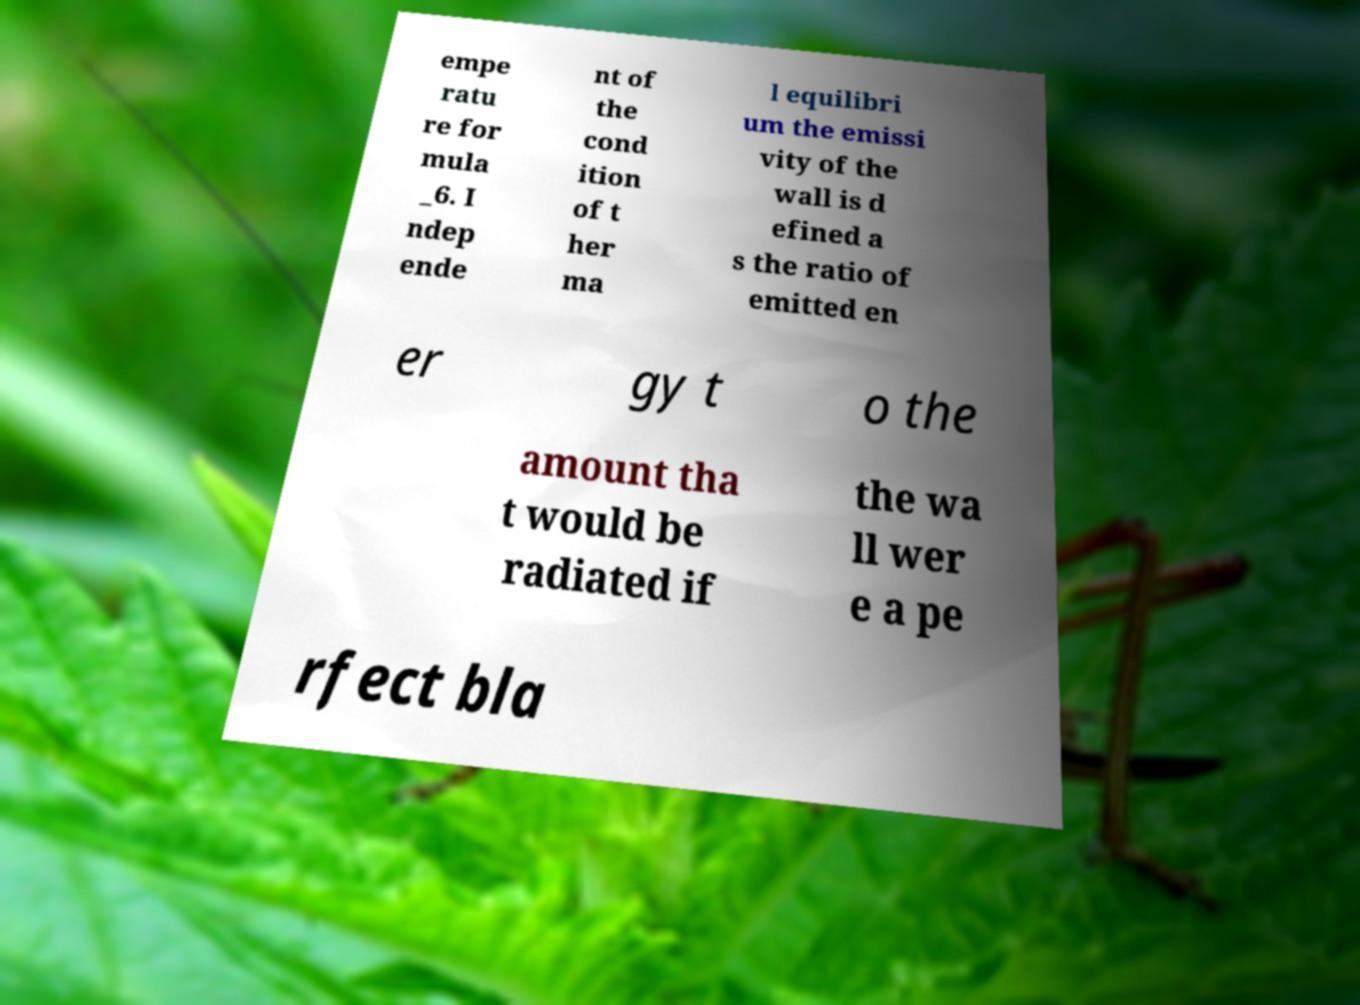I need the written content from this picture converted into text. Can you do that? empe ratu re for mula _6. I ndep ende nt of the cond ition of t her ma l equilibri um the emissi vity of the wall is d efined a s the ratio of emitted en er gy t o the amount tha t would be radiated if the wa ll wer e a pe rfect bla 